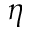Convert formula to latex. <formula><loc_0><loc_0><loc_500><loc_500>\eta</formula> 